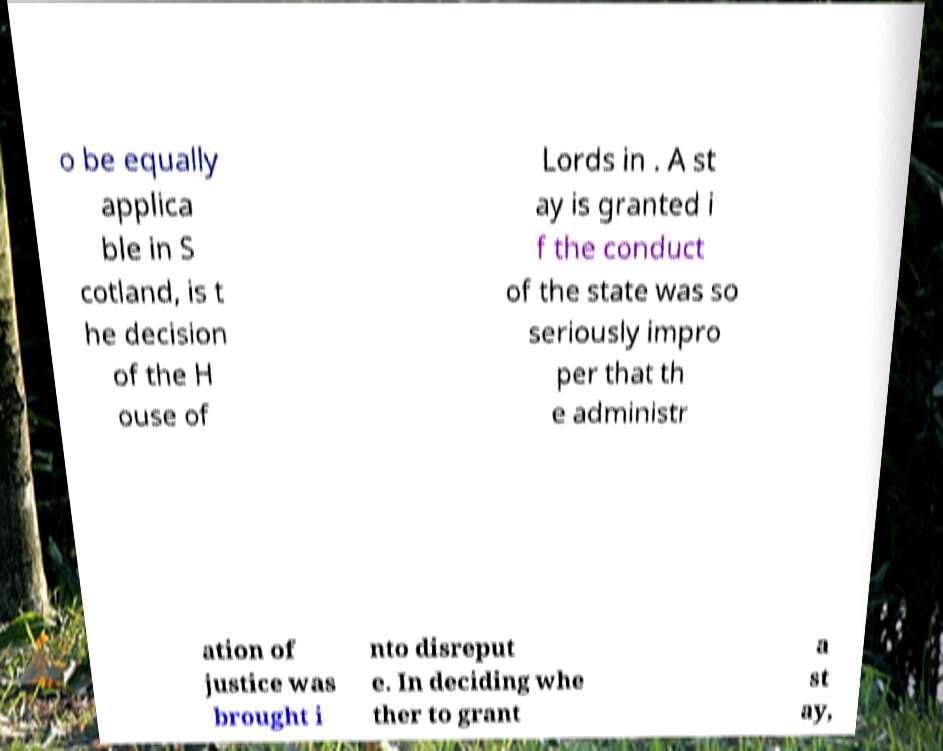For documentation purposes, I need the text within this image transcribed. Could you provide that? o be equally applica ble in S cotland, is t he decision of the H ouse of Lords in . A st ay is granted i f the conduct of the state was so seriously impro per that th e administr ation of justice was brought i nto disreput e. In deciding whe ther to grant a st ay, 